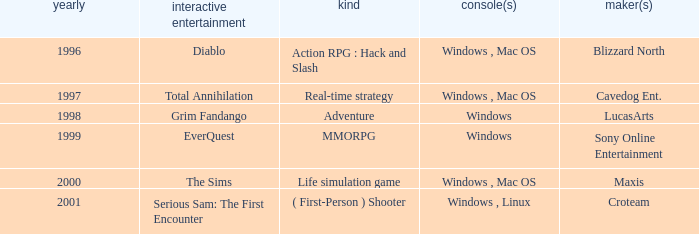What game in the genre of adventure, has a windows platform and its year is after 1997? Grim Fandango. 